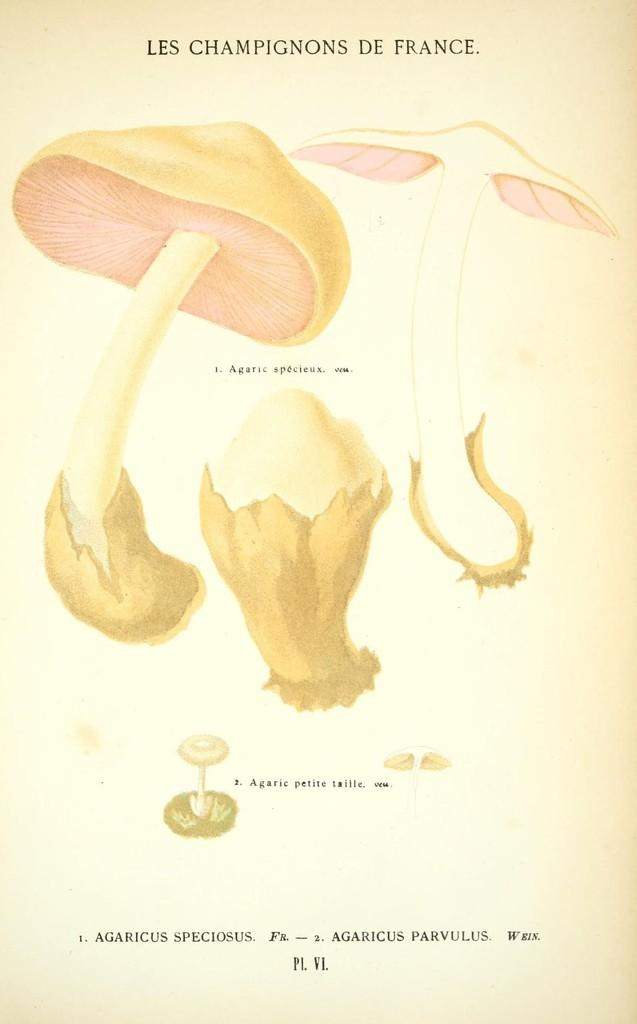What is depicted in the drawing in the image? There is a drawing of mushrooms in the image. What is the drawing on? The drawing is on a paper. What color is the background of the image? The background color is cream. What can be found at the bottom of the image? There is some text at the bottom of the image. Can you tell me how many sisters are mentioned in the text at the bottom of the image? There is no mention of sisters in the text at the bottom of the image. What type of stitch is used to create the drawing of mushrooms? The drawing is not a physical object, so it cannot be stitched; it is a drawing on paper. 